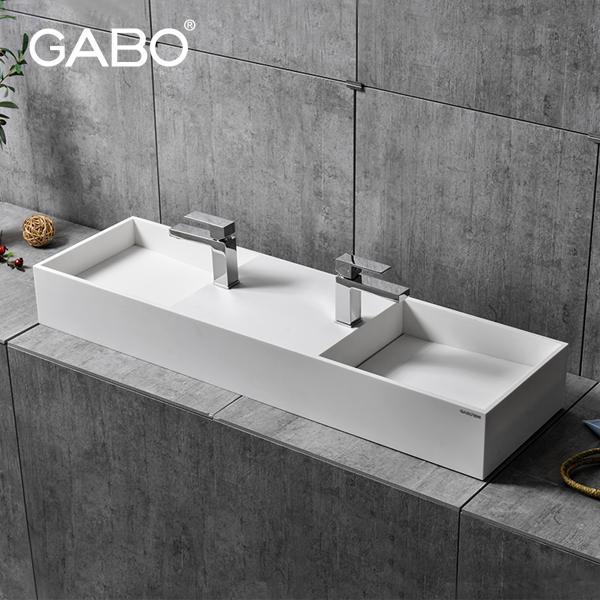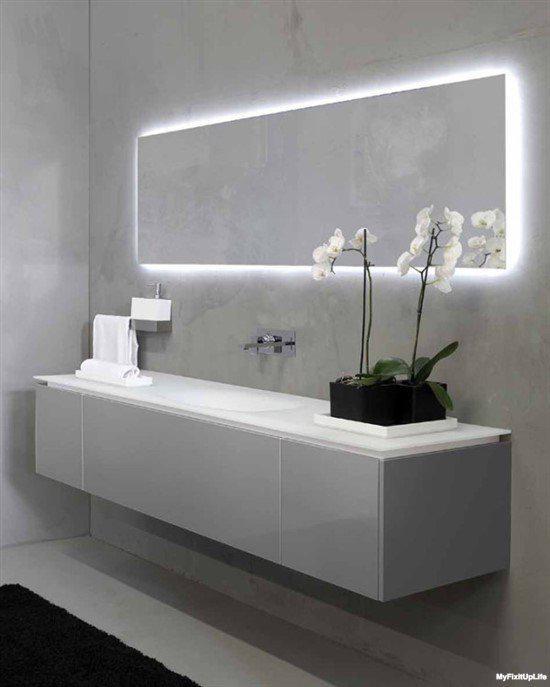The first image is the image on the left, the second image is the image on the right. Analyze the images presented: Is the assertion "Each image shows a white counter with a single undivided rectangular sink carved into it, and at least one image features a row of six spouts above the basin." valid? Answer yes or no. No. The first image is the image on the left, the second image is the image on the right. Considering the images on both sides, is "In at least one image there is at least one floating white sink sitting on top of a grey block." valid? Answer yes or no. Yes. 